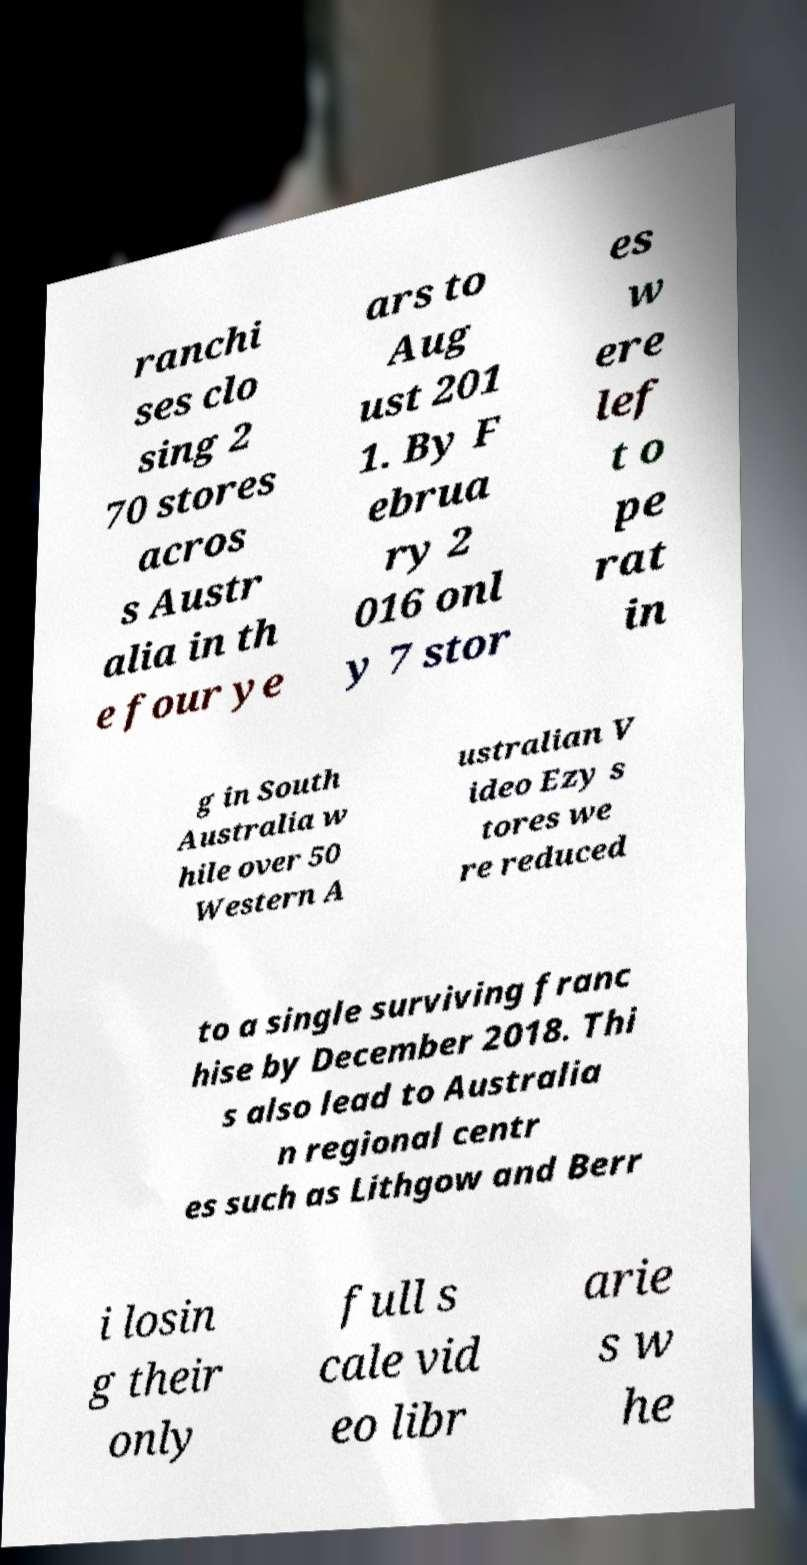Could you assist in decoding the text presented in this image and type it out clearly? ranchi ses clo sing 2 70 stores acros s Austr alia in th e four ye ars to Aug ust 201 1. By F ebrua ry 2 016 onl y 7 stor es w ere lef t o pe rat in g in South Australia w hile over 50 Western A ustralian V ideo Ezy s tores we re reduced to a single surviving franc hise by December 2018. Thi s also lead to Australia n regional centr es such as Lithgow and Berr i losin g their only full s cale vid eo libr arie s w he 